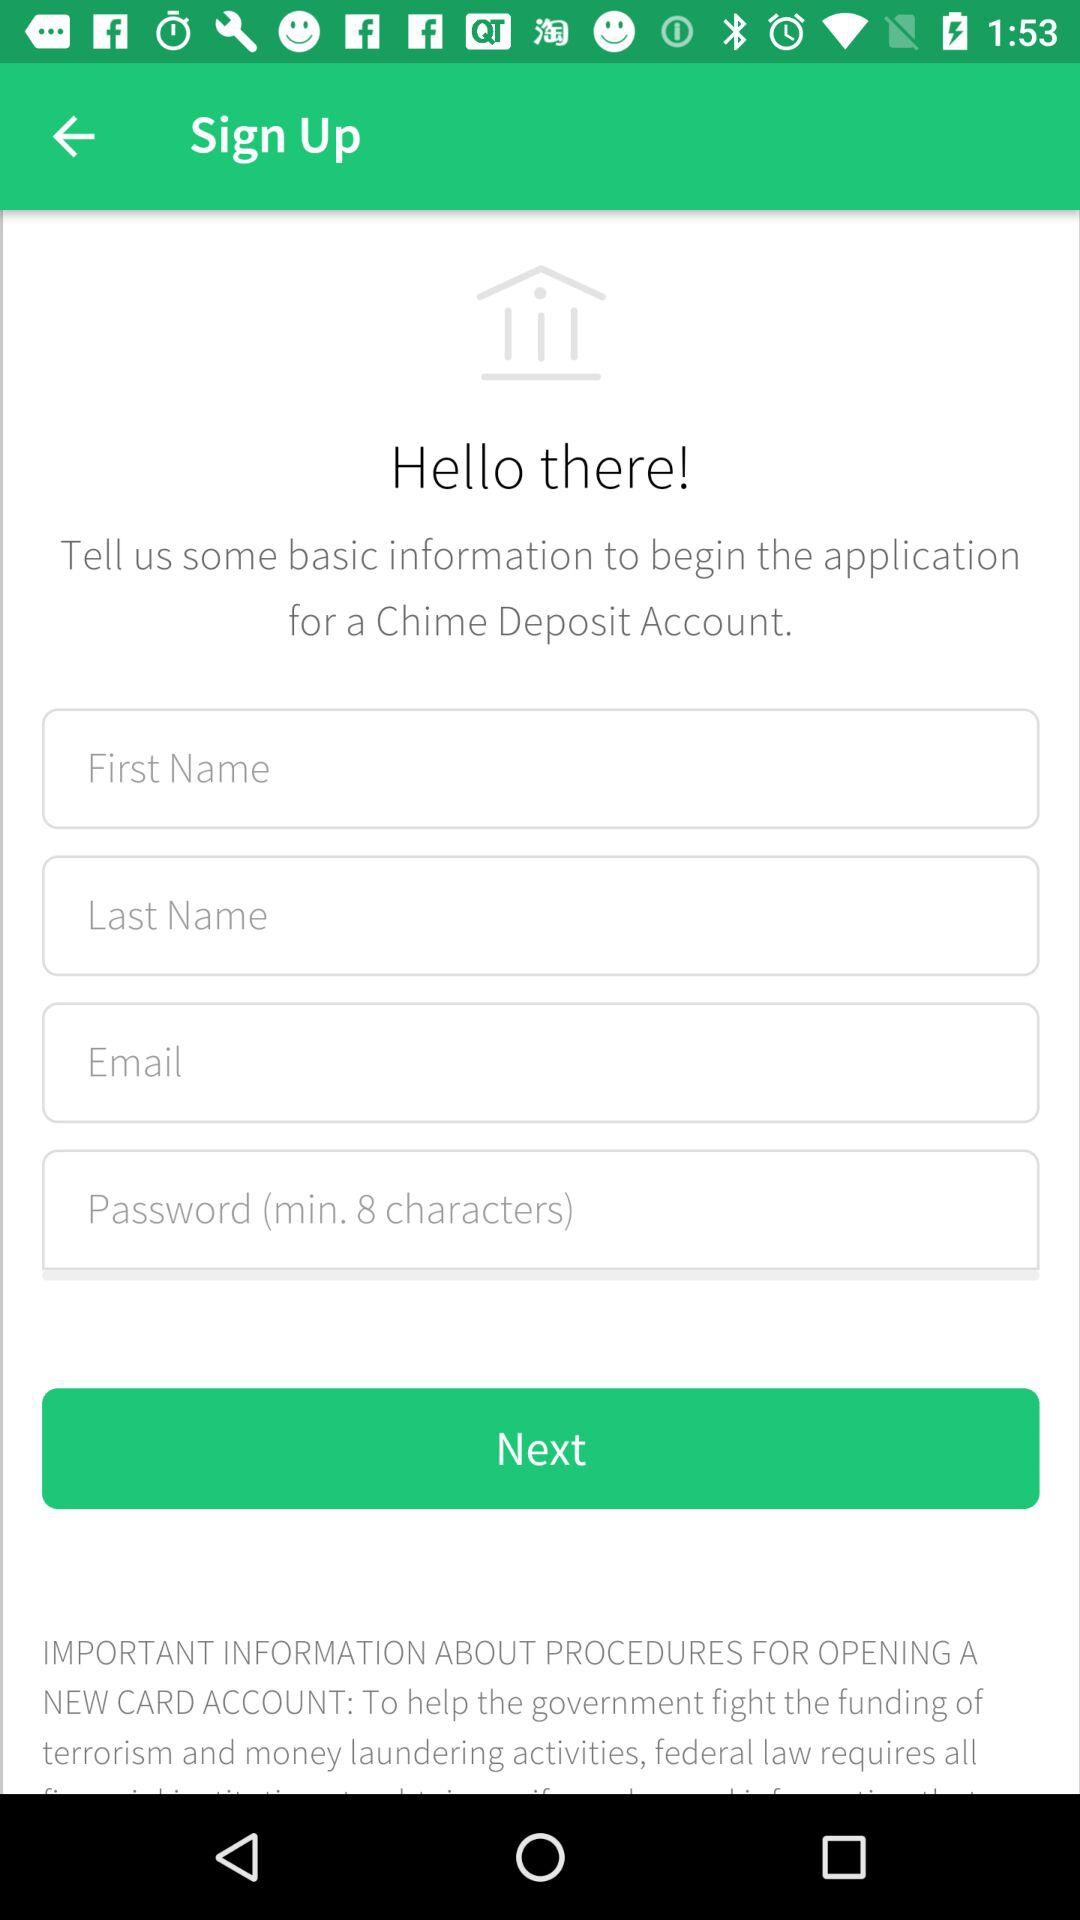What is the name of the application? The name of the application is "Chime". 